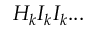<formula> <loc_0><loc_0><loc_500><loc_500>H _ { k } I _ { k } I _ { k } \dots</formula> 